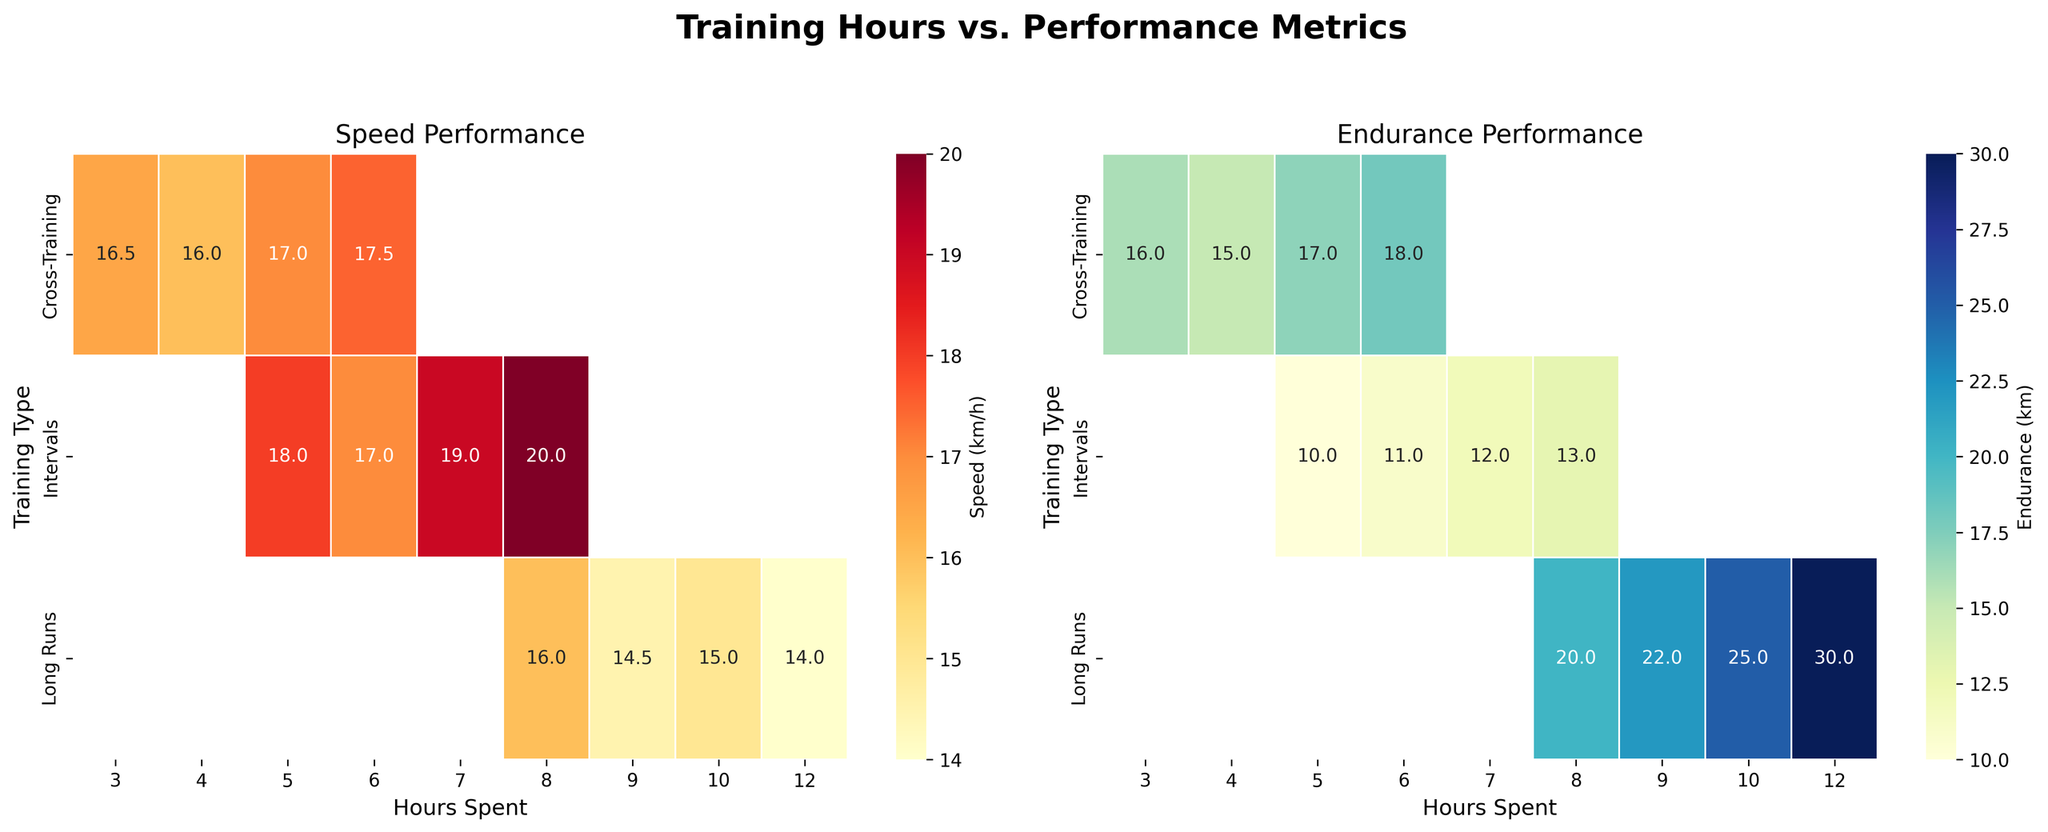How many training types are shown in the figure? There are three distinct training types shown on the y-axis of the heatmaps, which are Intervals, Long Runs, and Cross-Training.
Answer: 3 Which training type has the highest speed performance with 8 hours of training? Looking at the Speed Performance heatmap, for 8 hours of training, the highest speed value is 20 km/h under the Intervals training type.
Answer: Intervals What is the endurance performance for Long Runs with 12 hours of training? In the Endurance Performance heatmap, locate the cell where Long Runs intersects with 12 hours of training. The value in this cell is 30 km.
Answer: 30 km Which training type has a more consistent speed performance according to the heatmap? In the Speed Performance heatmap, compare the variability across different hours for each training type. Long Runs and Cross-Training show consistent values without drastic changes, but Cross-Training seems more stable around the 16-17.5 km/h range.
Answer: Cross-Training How does the speed performance change with increasing hours of Long Runs? By observing the speed values for Long Runs in the Speed Performance heatmap, as the hours increase from 8 to 12, the speed generally decreases from 16 km/h to 14 km/h.
Answer: Decreases Calculate the average speed for Intervals training type from the given figure. For Intervals, the speed values are 18, 19, 17, and 20 km/h. Adding these values gives 74, and the average is 74 / 4 = 18.5 km/h.
Answer: 18.5 km/h Compare the endurance performance between 5 hours of Intervals and 5 hours of Cross-Training. From the Endurance Performance heatmap, 5 hours of Intervals have an endurance of 10 km, whereas 5 hours of Cross-Training have an endurance of 17 km. 17 km is greater than 10 km.
Answer: Cross-Training What is the trend in endurance performance with increasing hours of Cross-Training? Observing the Endurance Performance heatmap for Cross-Training, as the hours increase from 3 to 6, the endurance performance gradually increases from 16 km to 18 km.
Answer: Increases What is the highest recorded speed value across all training types and hours? Check all the cells in the Speed Performance heatmap. The highest value observed is 20 km/h under Intervals for 8 hours of training.
Answer: 20 km/h Which training type shows the highest endurance performance at fewer than 5 hours of training? In the Endurance Performance heatmap, look at the values for hours less than 5. Cross-Training at 4 hours has the highest value of 15 km compared to the other types.
Answer: Cross-Training 